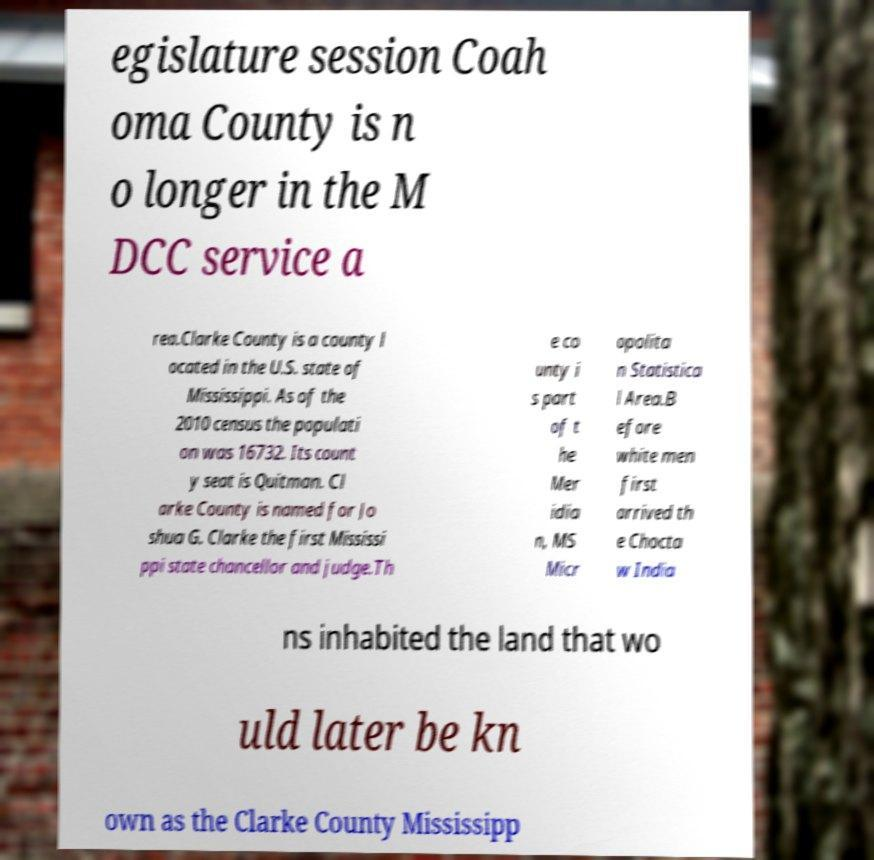Could you extract and type out the text from this image? egislature session Coah oma County is n o longer in the M DCC service a rea.Clarke County is a county l ocated in the U.S. state of Mississippi. As of the 2010 census the populati on was 16732. Its count y seat is Quitman. Cl arke County is named for Jo shua G. Clarke the first Mississi ppi state chancellor and judge.Th e co unty i s part of t he Mer idia n, MS Micr opolita n Statistica l Area.B efore white men first arrived th e Chocta w India ns inhabited the land that wo uld later be kn own as the Clarke County Mississipp 